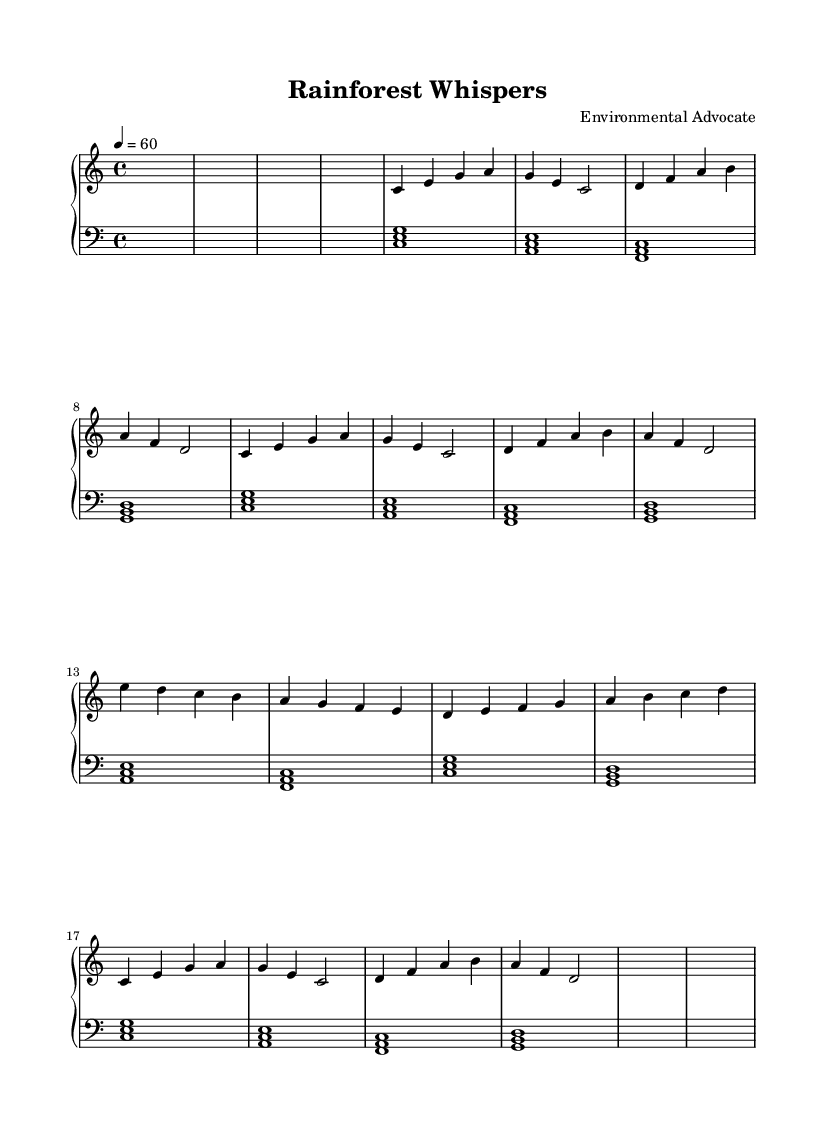What is the key signature of this music? The key signature is C major, which is indicated by the absence of sharps or flats at the beginning of the staff.
Answer: C major What is the time signature of this music? The time signature is indicated as 4/4, showing that there are four beats per measure and the quarter note gets one beat.
Answer: 4/4 What is the tempo marking for this piece? The tempo marking shows that the tempo is set at a quarter note equal to 60 beats per minute, which is a slow pace.
Answer: 60 How many sections are there in the piece? By analyzing the structure, we can identify sections labeled A and B, which appear in the order of A, B, A variation, and then an outro, leading to a total of three distinct sections: A, B, and the variation of A.
Answer: 3 What is the harmonic structure used in Section A? In Section A, the harmonic structure includes the chords C major, A minor, D minor, and G major, as the notes played suggest these chords based on their root notes and formations.
Answer: C, A minor, D minor, G Which instrument is primarily featured in this piece? The primary instrument featured in this piece is the piano, indicated by the staff labeled 'PianoStaff' that consists of treble and bass clefs for the piano's range.
Answer: Piano What musical style does this piece represent? This piece represents the experimental musical style, as inferred from the nature-inspired title "Rainforest Whispers" and the use of ambient soundscapes alongside field recordings from endangered ecosystems.
Answer: Experimental 